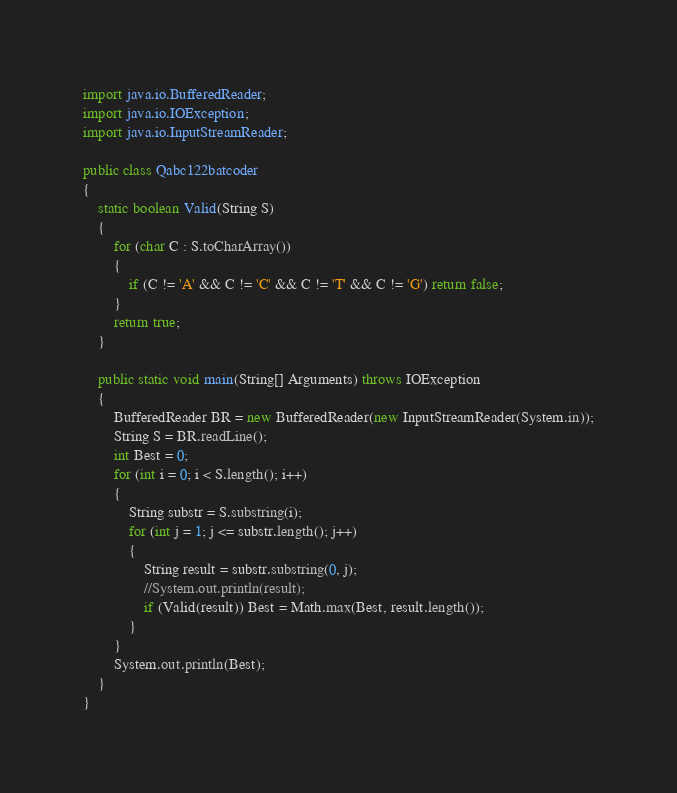Convert code to text. <code><loc_0><loc_0><loc_500><loc_500><_Java_>import java.io.BufferedReader;
import java.io.IOException;
import java.io.InputStreamReader;

public class Qabc122batcoder 
{
	static boolean Valid(String S)
	{
		for (char C : S.toCharArray())
		{
			if (C != 'A' && C != 'C' && C != 'T' && C != 'G') return false;
		}
		return true;
	}
	
	public static void main(String[] Arguments) throws IOException 
	{
		BufferedReader BR = new BufferedReader(new InputStreamReader(System.in));
		String S = BR.readLine();
		int Best = 0;
		for (int i = 0; i < S.length(); i++)
		{
			String substr = S.substring(i);
			for (int j = 1; j <= substr.length(); j++)
			{
				String result = substr.substring(0, j);
				//System.out.println(result);
				if (Valid(result)) Best = Math.max(Best, result.length());
			}
		}
		System.out.println(Best);
	}
}
</code> 